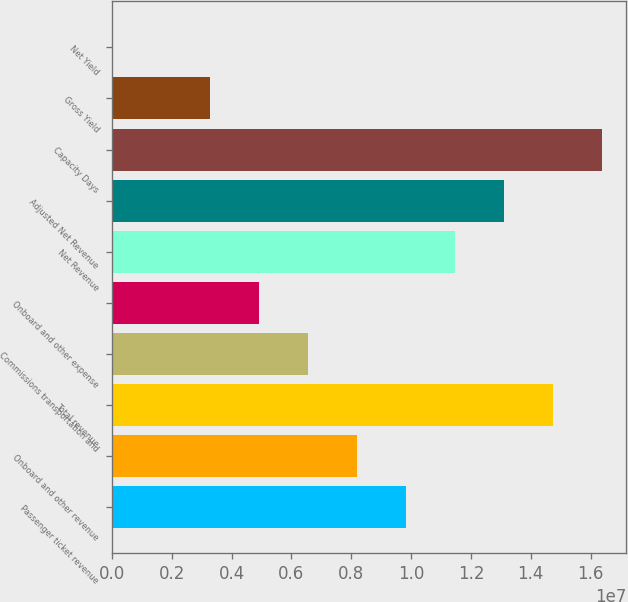Convert chart. <chart><loc_0><loc_0><loc_500><loc_500><bar_chart><fcel>Passenger ticket revenue<fcel>Onboard and other revenue<fcel>Total revenue<fcel>Commissions transportation and<fcel>Onboard and other expense<fcel>Net Revenue<fcel>Adjusted Net Revenue<fcel>Capacity Days<fcel>Gross Yield<fcel>Net Yield<nl><fcel>9.82573e+06<fcel>8.18815e+06<fcel>1.47385e+07<fcel>6.55056e+06<fcel>4.91298e+06<fcel>1.14633e+07<fcel>1.31009e+07<fcel>1.63761e+07<fcel>3.2754e+06<fcel>231.18<nl></chart> 